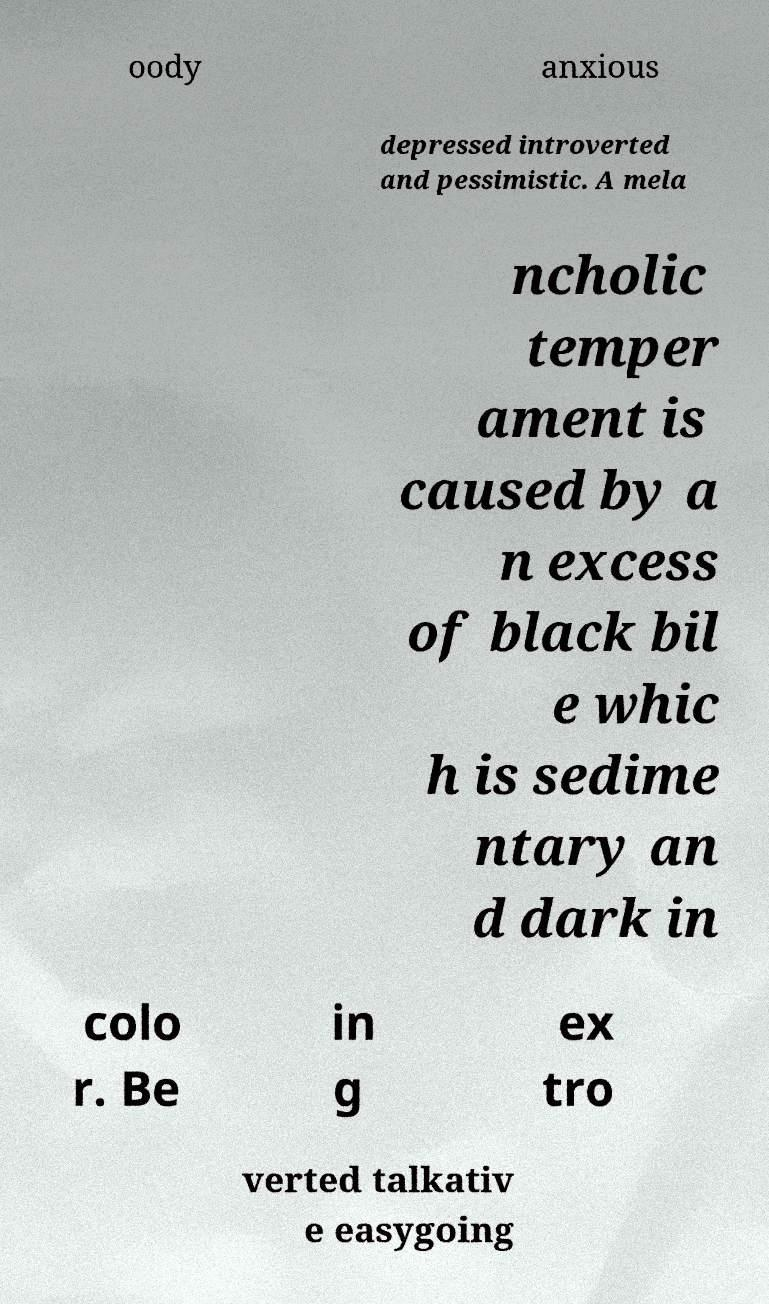I need the written content from this picture converted into text. Can you do that? oody anxious depressed introverted and pessimistic. A mela ncholic temper ament is caused by a n excess of black bil e whic h is sedime ntary an d dark in colo r. Be in g ex tro verted talkativ e easygoing 